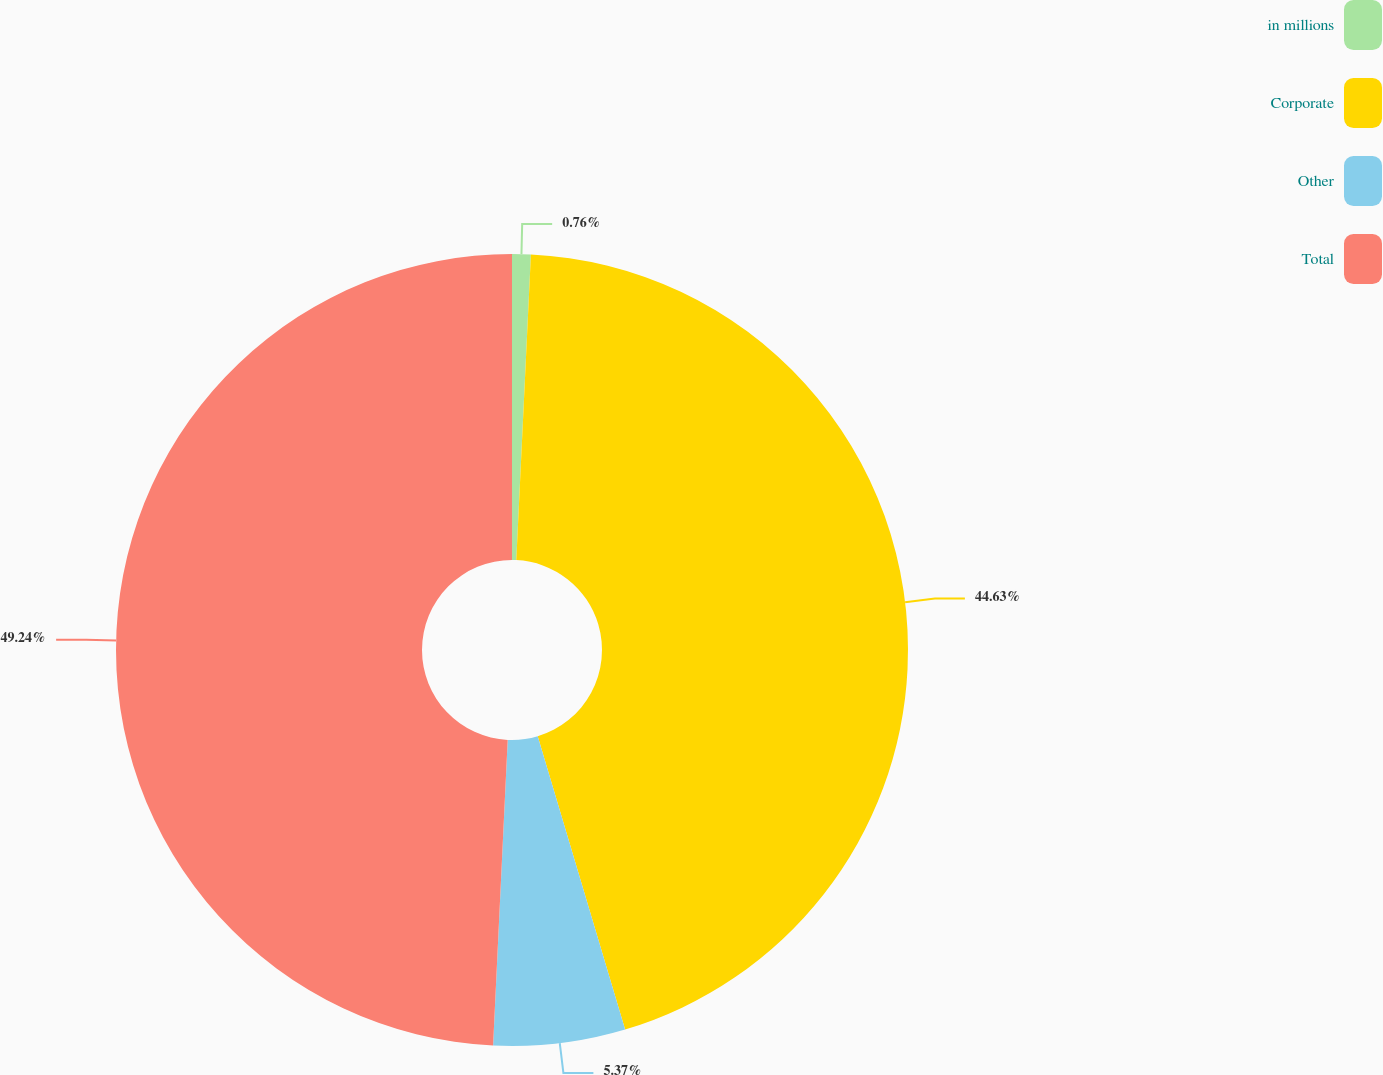Convert chart to OTSL. <chart><loc_0><loc_0><loc_500><loc_500><pie_chart><fcel>in millions<fcel>Corporate<fcel>Other<fcel>Total<nl><fcel>0.76%<fcel>44.63%<fcel>5.37%<fcel>49.24%<nl></chart> 